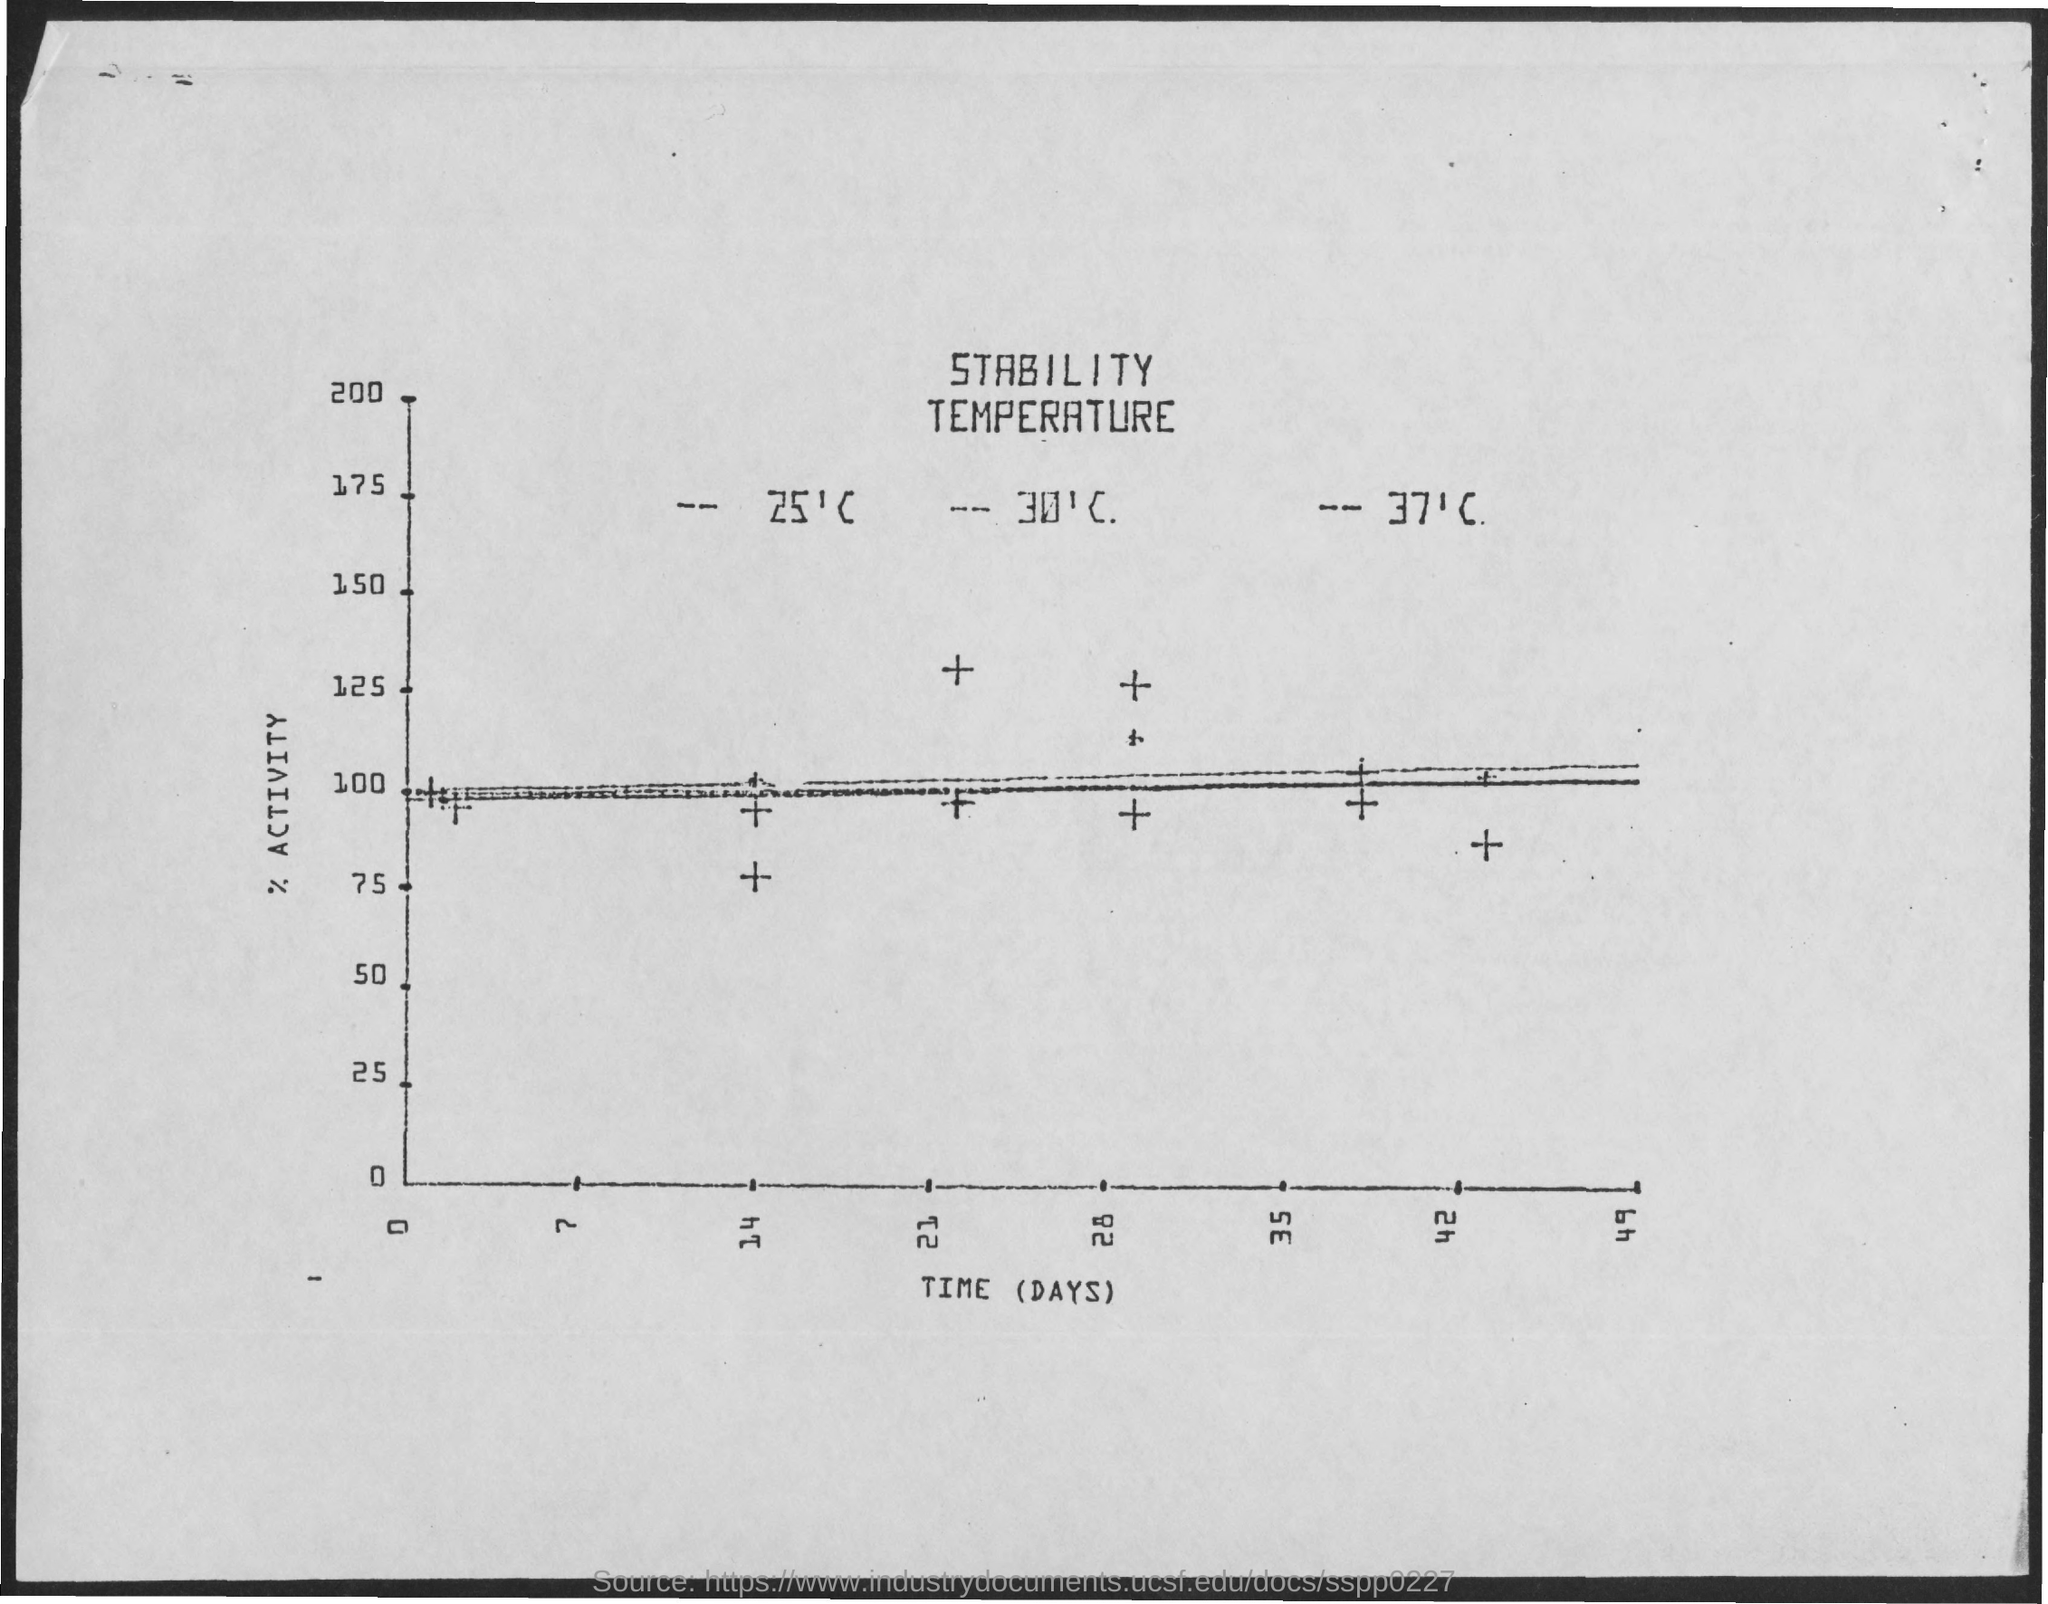What is plotted in the x-axis?
Your answer should be compact. Time (days). What is plotted in the y-axis?
Your answer should be very brief. % activity. 